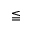<formula> <loc_0><loc_0><loc_500><loc_500>\leqq</formula> 